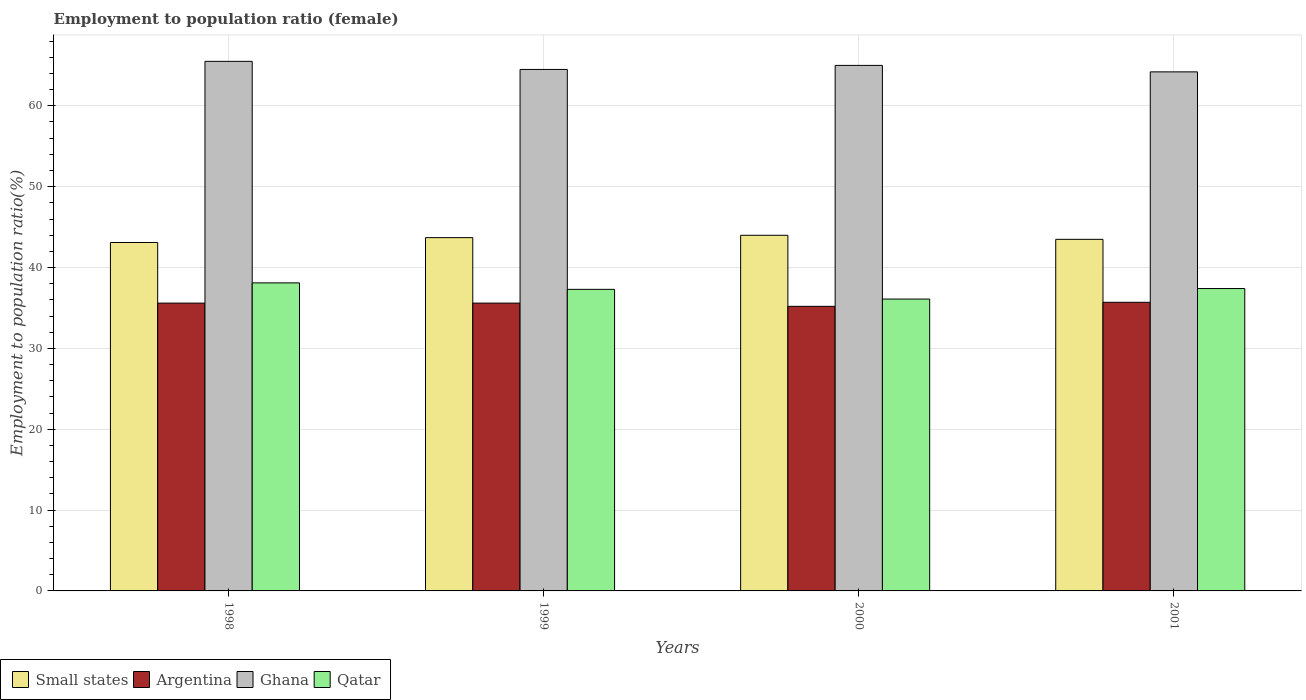Are the number of bars on each tick of the X-axis equal?
Offer a very short reply. Yes. How many bars are there on the 3rd tick from the right?
Your answer should be compact. 4. What is the label of the 4th group of bars from the left?
Offer a terse response. 2001. In how many cases, is the number of bars for a given year not equal to the number of legend labels?
Offer a very short reply. 0. What is the employment to population ratio in Qatar in 1999?
Keep it short and to the point. 37.3. Across all years, what is the maximum employment to population ratio in Qatar?
Provide a short and direct response. 38.1. Across all years, what is the minimum employment to population ratio in Small states?
Your answer should be compact. 43.1. In which year was the employment to population ratio in Qatar maximum?
Offer a very short reply. 1998. In which year was the employment to population ratio in Ghana minimum?
Your response must be concise. 2001. What is the total employment to population ratio in Ghana in the graph?
Keep it short and to the point. 259.2. What is the difference between the employment to population ratio in Ghana in 1998 and that in 2001?
Provide a succinct answer. 1.3. What is the difference between the employment to population ratio in Small states in 1998 and the employment to population ratio in Argentina in 2001?
Give a very brief answer. 7.4. What is the average employment to population ratio in Small states per year?
Your answer should be very brief. 43.57. In the year 2000, what is the difference between the employment to population ratio in Ghana and employment to population ratio in Qatar?
Provide a short and direct response. 28.9. In how many years, is the employment to population ratio in Small states greater than 66 %?
Offer a very short reply. 0. What is the ratio of the employment to population ratio in Argentina in 1998 to that in 2001?
Your answer should be compact. 1. What is the difference between the highest and the second highest employment to population ratio in Argentina?
Your answer should be very brief. 0.1. In how many years, is the employment to population ratio in Argentina greater than the average employment to population ratio in Argentina taken over all years?
Make the answer very short. 3. What does the 4th bar from the left in 2001 represents?
Provide a succinct answer. Qatar. What does the 1st bar from the right in 1999 represents?
Provide a succinct answer. Qatar. How many bars are there?
Your answer should be compact. 16. Are all the bars in the graph horizontal?
Your answer should be very brief. No. What is the difference between two consecutive major ticks on the Y-axis?
Make the answer very short. 10. Does the graph contain grids?
Keep it short and to the point. Yes. How many legend labels are there?
Provide a short and direct response. 4. What is the title of the graph?
Your response must be concise. Employment to population ratio (female). Does "Zambia" appear as one of the legend labels in the graph?
Provide a succinct answer. No. What is the Employment to population ratio(%) of Small states in 1998?
Make the answer very short. 43.1. What is the Employment to population ratio(%) in Argentina in 1998?
Give a very brief answer. 35.6. What is the Employment to population ratio(%) of Ghana in 1998?
Give a very brief answer. 65.5. What is the Employment to population ratio(%) of Qatar in 1998?
Give a very brief answer. 38.1. What is the Employment to population ratio(%) in Small states in 1999?
Your answer should be compact. 43.7. What is the Employment to population ratio(%) in Argentina in 1999?
Keep it short and to the point. 35.6. What is the Employment to population ratio(%) in Ghana in 1999?
Your response must be concise. 64.5. What is the Employment to population ratio(%) of Qatar in 1999?
Make the answer very short. 37.3. What is the Employment to population ratio(%) of Small states in 2000?
Give a very brief answer. 43.99. What is the Employment to population ratio(%) of Argentina in 2000?
Provide a succinct answer. 35.2. What is the Employment to population ratio(%) of Qatar in 2000?
Offer a very short reply. 36.1. What is the Employment to population ratio(%) of Small states in 2001?
Offer a terse response. 43.49. What is the Employment to population ratio(%) in Argentina in 2001?
Ensure brevity in your answer.  35.7. What is the Employment to population ratio(%) of Ghana in 2001?
Offer a terse response. 64.2. What is the Employment to population ratio(%) in Qatar in 2001?
Provide a succinct answer. 37.4. Across all years, what is the maximum Employment to population ratio(%) of Small states?
Offer a very short reply. 43.99. Across all years, what is the maximum Employment to population ratio(%) of Argentina?
Keep it short and to the point. 35.7. Across all years, what is the maximum Employment to population ratio(%) in Ghana?
Provide a succinct answer. 65.5. Across all years, what is the maximum Employment to population ratio(%) in Qatar?
Provide a succinct answer. 38.1. Across all years, what is the minimum Employment to population ratio(%) in Small states?
Provide a short and direct response. 43.1. Across all years, what is the minimum Employment to population ratio(%) in Argentina?
Your answer should be compact. 35.2. Across all years, what is the minimum Employment to population ratio(%) of Ghana?
Ensure brevity in your answer.  64.2. Across all years, what is the minimum Employment to population ratio(%) in Qatar?
Your response must be concise. 36.1. What is the total Employment to population ratio(%) in Small states in the graph?
Make the answer very short. 174.27. What is the total Employment to population ratio(%) in Argentina in the graph?
Give a very brief answer. 142.1. What is the total Employment to population ratio(%) of Ghana in the graph?
Your response must be concise. 259.2. What is the total Employment to population ratio(%) of Qatar in the graph?
Offer a very short reply. 148.9. What is the difference between the Employment to population ratio(%) of Small states in 1998 and that in 1999?
Give a very brief answer. -0.6. What is the difference between the Employment to population ratio(%) in Ghana in 1998 and that in 1999?
Offer a very short reply. 1. What is the difference between the Employment to population ratio(%) in Small states in 1998 and that in 2000?
Give a very brief answer. -0.89. What is the difference between the Employment to population ratio(%) in Small states in 1998 and that in 2001?
Provide a short and direct response. -0.39. What is the difference between the Employment to population ratio(%) of Argentina in 1998 and that in 2001?
Your answer should be very brief. -0.1. What is the difference between the Employment to population ratio(%) in Ghana in 1998 and that in 2001?
Provide a short and direct response. 1.3. What is the difference between the Employment to population ratio(%) in Small states in 1999 and that in 2000?
Your answer should be very brief. -0.29. What is the difference between the Employment to population ratio(%) in Small states in 1999 and that in 2001?
Provide a succinct answer. 0.21. What is the difference between the Employment to population ratio(%) in Qatar in 1999 and that in 2001?
Offer a terse response. -0.1. What is the difference between the Employment to population ratio(%) in Small states in 2000 and that in 2001?
Provide a succinct answer. 0.5. What is the difference between the Employment to population ratio(%) in Ghana in 2000 and that in 2001?
Provide a short and direct response. 0.8. What is the difference between the Employment to population ratio(%) in Qatar in 2000 and that in 2001?
Ensure brevity in your answer.  -1.3. What is the difference between the Employment to population ratio(%) of Small states in 1998 and the Employment to population ratio(%) of Argentina in 1999?
Provide a succinct answer. 7.5. What is the difference between the Employment to population ratio(%) of Small states in 1998 and the Employment to population ratio(%) of Ghana in 1999?
Offer a terse response. -21.4. What is the difference between the Employment to population ratio(%) in Small states in 1998 and the Employment to population ratio(%) in Qatar in 1999?
Your answer should be very brief. 5.8. What is the difference between the Employment to population ratio(%) of Argentina in 1998 and the Employment to population ratio(%) of Ghana in 1999?
Your answer should be very brief. -28.9. What is the difference between the Employment to population ratio(%) in Argentina in 1998 and the Employment to population ratio(%) in Qatar in 1999?
Make the answer very short. -1.7. What is the difference between the Employment to population ratio(%) of Ghana in 1998 and the Employment to population ratio(%) of Qatar in 1999?
Ensure brevity in your answer.  28.2. What is the difference between the Employment to population ratio(%) in Small states in 1998 and the Employment to population ratio(%) in Argentina in 2000?
Your response must be concise. 7.9. What is the difference between the Employment to population ratio(%) of Small states in 1998 and the Employment to population ratio(%) of Ghana in 2000?
Your answer should be very brief. -21.9. What is the difference between the Employment to population ratio(%) in Small states in 1998 and the Employment to population ratio(%) in Qatar in 2000?
Your response must be concise. 7. What is the difference between the Employment to population ratio(%) in Argentina in 1998 and the Employment to population ratio(%) in Ghana in 2000?
Offer a very short reply. -29.4. What is the difference between the Employment to population ratio(%) of Ghana in 1998 and the Employment to population ratio(%) of Qatar in 2000?
Ensure brevity in your answer.  29.4. What is the difference between the Employment to population ratio(%) in Small states in 1998 and the Employment to population ratio(%) in Argentina in 2001?
Your response must be concise. 7.4. What is the difference between the Employment to population ratio(%) in Small states in 1998 and the Employment to population ratio(%) in Ghana in 2001?
Offer a terse response. -21.1. What is the difference between the Employment to population ratio(%) in Small states in 1998 and the Employment to population ratio(%) in Qatar in 2001?
Offer a terse response. 5.7. What is the difference between the Employment to population ratio(%) in Argentina in 1998 and the Employment to population ratio(%) in Ghana in 2001?
Provide a short and direct response. -28.6. What is the difference between the Employment to population ratio(%) in Argentina in 1998 and the Employment to population ratio(%) in Qatar in 2001?
Your answer should be very brief. -1.8. What is the difference between the Employment to population ratio(%) of Ghana in 1998 and the Employment to population ratio(%) of Qatar in 2001?
Make the answer very short. 28.1. What is the difference between the Employment to population ratio(%) in Small states in 1999 and the Employment to population ratio(%) in Argentina in 2000?
Provide a succinct answer. 8.5. What is the difference between the Employment to population ratio(%) in Small states in 1999 and the Employment to population ratio(%) in Ghana in 2000?
Make the answer very short. -21.3. What is the difference between the Employment to population ratio(%) of Small states in 1999 and the Employment to population ratio(%) of Qatar in 2000?
Provide a short and direct response. 7.6. What is the difference between the Employment to population ratio(%) of Argentina in 1999 and the Employment to population ratio(%) of Ghana in 2000?
Offer a terse response. -29.4. What is the difference between the Employment to population ratio(%) in Ghana in 1999 and the Employment to population ratio(%) in Qatar in 2000?
Offer a terse response. 28.4. What is the difference between the Employment to population ratio(%) in Small states in 1999 and the Employment to population ratio(%) in Argentina in 2001?
Make the answer very short. 8. What is the difference between the Employment to population ratio(%) in Small states in 1999 and the Employment to population ratio(%) in Ghana in 2001?
Make the answer very short. -20.5. What is the difference between the Employment to population ratio(%) of Small states in 1999 and the Employment to population ratio(%) of Qatar in 2001?
Your response must be concise. 6.3. What is the difference between the Employment to population ratio(%) in Argentina in 1999 and the Employment to population ratio(%) in Ghana in 2001?
Your answer should be very brief. -28.6. What is the difference between the Employment to population ratio(%) in Argentina in 1999 and the Employment to population ratio(%) in Qatar in 2001?
Make the answer very short. -1.8. What is the difference between the Employment to population ratio(%) of Ghana in 1999 and the Employment to population ratio(%) of Qatar in 2001?
Keep it short and to the point. 27.1. What is the difference between the Employment to population ratio(%) of Small states in 2000 and the Employment to population ratio(%) of Argentina in 2001?
Offer a terse response. 8.29. What is the difference between the Employment to population ratio(%) in Small states in 2000 and the Employment to population ratio(%) in Ghana in 2001?
Make the answer very short. -20.21. What is the difference between the Employment to population ratio(%) in Small states in 2000 and the Employment to population ratio(%) in Qatar in 2001?
Your answer should be very brief. 6.59. What is the difference between the Employment to population ratio(%) of Argentina in 2000 and the Employment to population ratio(%) of Qatar in 2001?
Provide a short and direct response. -2.2. What is the difference between the Employment to population ratio(%) in Ghana in 2000 and the Employment to population ratio(%) in Qatar in 2001?
Your answer should be very brief. 27.6. What is the average Employment to population ratio(%) of Small states per year?
Offer a very short reply. 43.57. What is the average Employment to population ratio(%) of Argentina per year?
Keep it short and to the point. 35.52. What is the average Employment to population ratio(%) of Ghana per year?
Provide a succinct answer. 64.8. What is the average Employment to population ratio(%) in Qatar per year?
Ensure brevity in your answer.  37.23. In the year 1998, what is the difference between the Employment to population ratio(%) in Small states and Employment to population ratio(%) in Argentina?
Provide a succinct answer. 7.5. In the year 1998, what is the difference between the Employment to population ratio(%) in Small states and Employment to population ratio(%) in Ghana?
Make the answer very short. -22.4. In the year 1998, what is the difference between the Employment to population ratio(%) in Small states and Employment to population ratio(%) in Qatar?
Make the answer very short. 5. In the year 1998, what is the difference between the Employment to population ratio(%) of Argentina and Employment to population ratio(%) of Ghana?
Make the answer very short. -29.9. In the year 1998, what is the difference between the Employment to population ratio(%) in Argentina and Employment to population ratio(%) in Qatar?
Offer a terse response. -2.5. In the year 1998, what is the difference between the Employment to population ratio(%) of Ghana and Employment to population ratio(%) of Qatar?
Make the answer very short. 27.4. In the year 1999, what is the difference between the Employment to population ratio(%) in Small states and Employment to population ratio(%) in Argentina?
Offer a terse response. 8.1. In the year 1999, what is the difference between the Employment to population ratio(%) of Small states and Employment to population ratio(%) of Ghana?
Provide a short and direct response. -20.8. In the year 1999, what is the difference between the Employment to population ratio(%) of Small states and Employment to population ratio(%) of Qatar?
Offer a very short reply. 6.4. In the year 1999, what is the difference between the Employment to population ratio(%) in Argentina and Employment to population ratio(%) in Ghana?
Your answer should be very brief. -28.9. In the year 1999, what is the difference between the Employment to population ratio(%) in Argentina and Employment to population ratio(%) in Qatar?
Ensure brevity in your answer.  -1.7. In the year 1999, what is the difference between the Employment to population ratio(%) in Ghana and Employment to population ratio(%) in Qatar?
Keep it short and to the point. 27.2. In the year 2000, what is the difference between the Employment to population ratio(%) in Small states and Employment to population ratio(%) in Argentina?
Your answer should be very brief. 8.79. In the year 2000, what is the difference between the Employment to population ratio(%) of Small states and Employment to population ratio(%) of Ghana?
Give a very brief answer. -21.01. In the year 2000, what is the difference between the Employment to population ratio(%) in Small states and Employment to population ratio(%) in Qatar?
Provide a short and direct response. 7.89. In the year 2000, what is the difference between the Employment to population ratio(%) in Argentina and Employment to population ratio(%) in Ghana?
Offer a very short reply. -29.8. In the year 2000, what is the difference between the Employment to population ratio(%) in Ghana and Employment to population ratio(%) in Qatar?
Your response must be concise. 28.9. In the year 2001, what is the difference between the Employment to population ratio(%) of Small states and Employment to population ratio(%) of Argentina?
Keep it short and to the point. 7.79. In the year 2001, what is the difference between the Employment to population ratio(%) of Small states and Employment to population ratio(%) of Ghana?
Provide a short and direct response. -20.71. In the year 2001, what is the difference between the Employment to population ratio(%) of Small states and Employment to population ratio(%) of Qatar?
Make the answer very short. 6.09. In the year 2001, what is the difference between the Employment to population ratio(%) of Argentina and Employment to population ratio(%) of Ghana?
Your response must be concise. -28.5. In the year 2001, what is the difference between the Employment to population ratio(%) of Argentina and Employment to population ratio(%) of Qatar?
Give a very brief answer. -1.7. In the year 2001, what is the difference between the Employment to population ratio(%) of Ghana and Employment to population ratio(%) of Qatar?
Provide a short and direct response. 26.8. What is the ratio of the Employment to population ratio(%) of Small states in 1998 to that in 1999?
Give a very brief answer. 0.99. What is the ratio of the Employment to population ratio(%) of Argentina in 1998 to that in 1999?
Give a very brief answer. 1. What is the ratio of the Employment to population ratio(%) of Ghana in 1998 to that in 1999?
Your answer should be compact. 1.02. What is the ratio of the Employment to population ratio(%) in Qatar in 1998 to that in 1999?
Offer a very short reply. 1.02. What is the ratio of the Employment to population ratio(%) of Small states in 1998 to that in 2000?
Give a very brief answer. 0.98. What is the ratio of the Employment to population ratio(%) in Argentina in 1998 to that in 2000?
Make the answer very short. 1.01. What is the ratio of the Employment to population ratio(%) in Ghana in 1998 to that in 2000?
Offer a very short reply. 1.01. What is the ratio of the Employment to population ratio(%) of Qatar in 1998 to that in 2000?
Offer a very short reply. 1.06. What is the ratio of the Employment to population ratio(%) of Small states in 1998 to that in 2001?
Provide a succinct answer. 0.99. What is the ratio of the Employment to population ratio(%) of Ghana in 1998 to that in 2001?
Your answer should be compact. 1.02. What is the ratio of the Employment to population ratio(%) in Qatar in 1998 to that in 2001?
Ensure brevity in your answer.  1.02. What is the ratio of the Employment to population ratio(%) of Small states in 1999 to that in 2000?
Offer a terse response. 0.99. What is the ratio of the Employment to population ratio(%) in Argentina in 1999 to that in 2000?
Ensure brevity in your answer.  1.01. What is the ratio of the Employment to population ratio(%) in Qatar in 1999 to that in 2000?
Make the answer very short. 1.03. What is the ratio of the Employment to population ratio(%) in Small states in 1999 to that in 2001?
Ensure brevity in your answer.  1. What is the ratio of the Employment to population ratio(%) of Argentina in 1999 to that in 2001?
Offer a terse response. 1. What is the ratio of the Employment to population ratio(%) in Small states in 2000 to that in 2001?
Your answer should be compact. 1.01. What is the ratio of the Employment to population ratio(%) of Argentina in 2000 to that in 2001?
Your answer should be very brief. 0.99. What is the ratio of the Employment to population ratio(%) in Ghana in 2000 to that in 2001?
Ensure brevity in your answer.  1.01. What is the ratio of the Employment to population ratio(%) of Qatar in 2000 to that in 2001?
Make the answer very short. 0.97. What is the difference between the highest and the second highest Employment to population ratio(%) of Small states?
Your response must be concise. 0.29. What is the difference between the highest and the second highest Employment to population ratio(%) in Qatar?
Your response must be concise. 0.7. What is the difference between the highest and the lowest Employment to population ratio(%) of Small states?
Ensure brevity in your answer.  0.89. What is the difference between the highest and the lowest Employment to population ratio(%) of Qatar?
Provide a short and direct response. 2. 